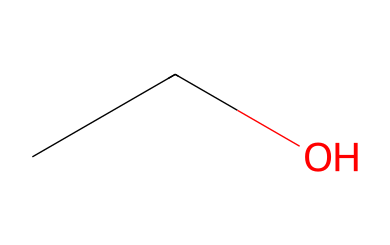What is the name of this chemical? The SMILES representation "CCO" indicates an ethanol molecule, which has a common name and is widely recognized as the standard alcohol found in beverages.
Answer: ethanol How many carbon atoms are in this chemical? Examining the SMILES "CCO", there are two 'C' (carbon) symbols, which means there are 2 carbon atoms present in the molecule.
Answer: 2 How many hydrogen atoms are in this chemical? In the structure represented by "CCO", each carbon typically bonds with enough hydrogens to fulfill its tetravalency. The first carbon has 3 hydrogens, the second carbon has 2, and the hydroxyl group adds one more; thus, the total is 6 hydrogen atoms.
Answer: 6 What type of functional group is present in this chemical? The "O" in the SMILES "CCO" represents a hydroxyl (-OH) group, which indicates that the chemical is an alcohol due to the presence of this functional group.
Answer: hydroxyl Is this chemical polar or non-polar? The presence of the hydroxyl group (-OH) in the "CCO" structure makes this chemical polar because it can form hydrogen bonds, which typically affect solubility in water.
Answer: polar What type of molecule is represented by this chemical? Given that the structure in SMILES form "CCO" corresponds with the characteristics of alcohols, it can be classified specifically as a simple alcohol, which is a type of organic molecule.
Answer: alcohol 